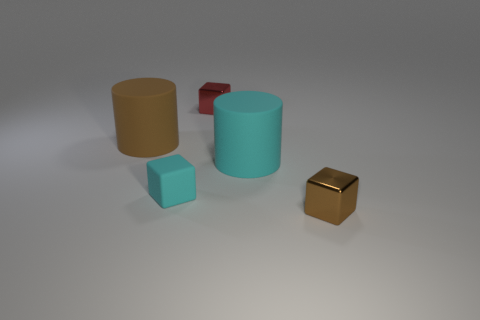Add 2 tiny brown rubber objects. How many objects exist? 7 Subtract all blocks. How many objects are left? 2 Add 1 metal cubes. How many metal cubes exist? 3 Subtract 0 brown spheres. How many objects are left? 5 Subtract all small gray blocks. Subtract all cyan cylinders. How many objects are left? 4 Add 5 cyan rubber blocks. How many cyan rubber blocks are left? 6 